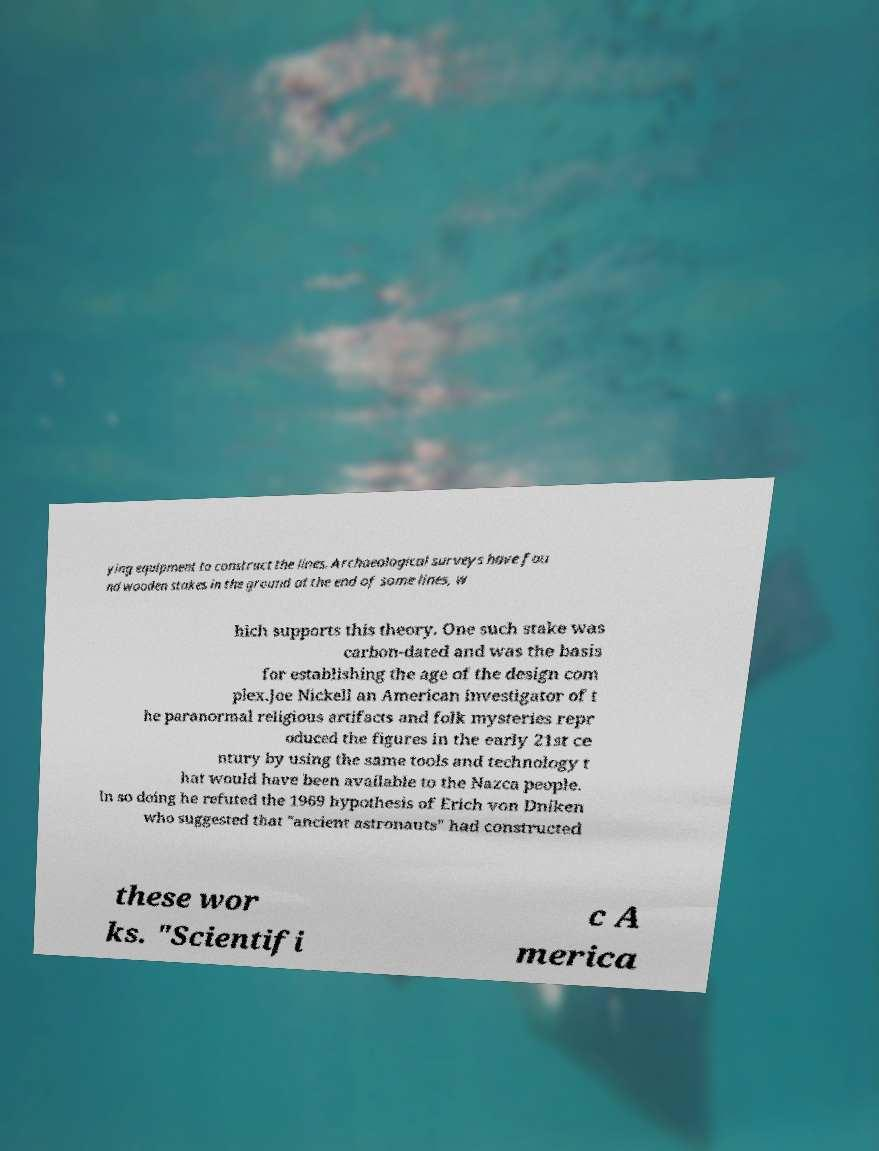Could you extract and type out the text from this image? ying equipment to construct the lines. Archaeological surveys have fou nd wooden stakes in the ground at the end of some lines, w hich supports this theory. One such stake was carbon-dated and was the basis for establishing the age of the design com plex.Joe Nickell an American investigator of t he paranormal religious artifacts and folk mysteries repr oduced the figures in the early 21st ce ntury by using the same tools and technology t hat would have been available to the Nazca people. In so doing he refuted the 1969 hypothesis of Erich von Dniken who suggested that "ancient astronauts" had constructed these wor ks. "Scientifi c A merica 